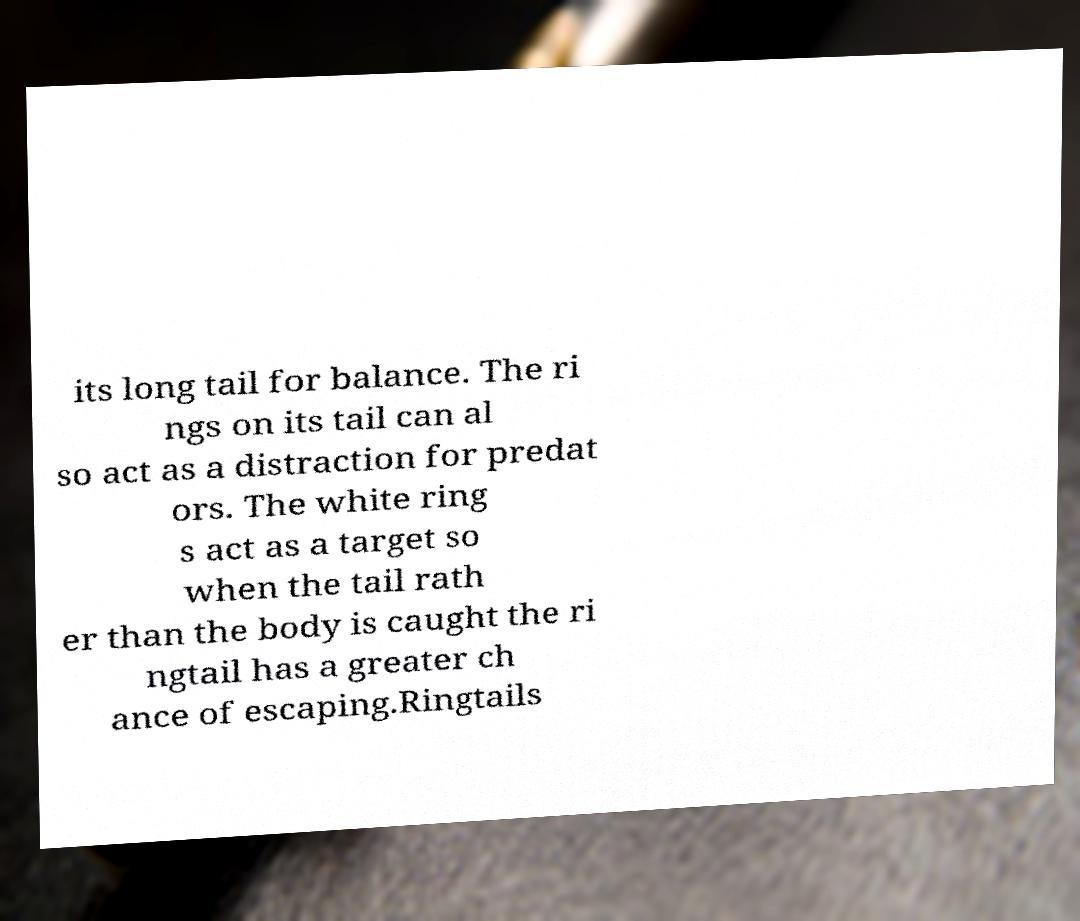For documentation purposes, I need the text within this image transcribed. Could you provide that? its long tail for balance. The ri ngs on its tail can al so act as a distraction for predat ors. The white ring s act as a target so when the tail rath er than the body is caught the ri ngtail has a greater ch ance of escaping.Ringtails 